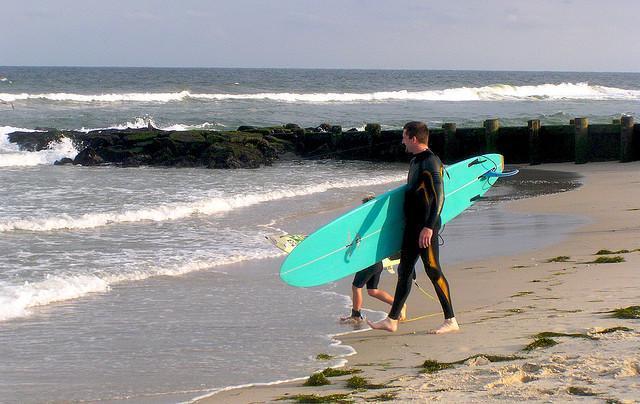How many people are in this picture?
Give a very brief answer. 2. How many blue skis are there?
Give a very brief answer. 0. 